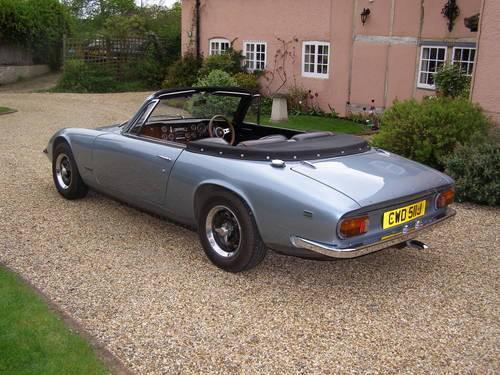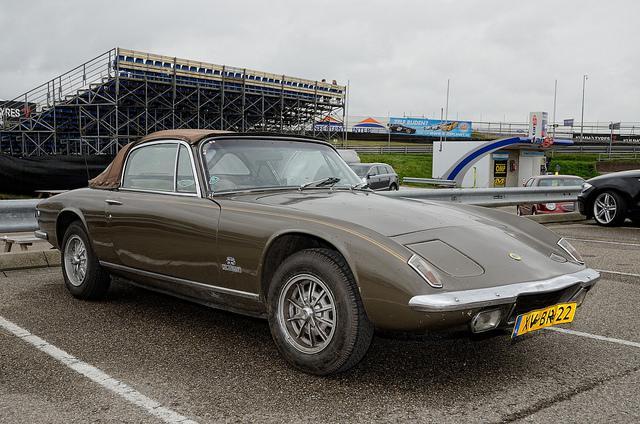The first image is the image on the left, the second image is the image on the right. For the images shown, is this caption "In one image, at least one car is parked on a brick pavement." true? Answer yes or no. No. 